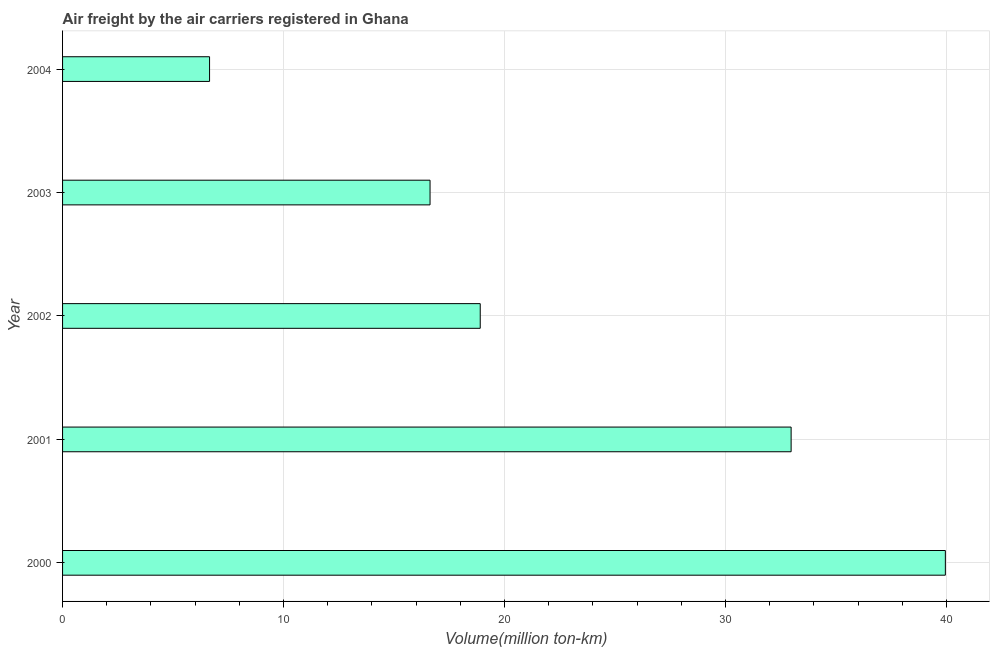Does the graph contain any zero values?
Offer a terse response. No. What is the title of the graph?
Your answer should be compact. Air freight by the air carriers registered in Ghana. What is the label or title of the X-axis?
Give a very brief answer. Volume(million ton-km). What is the air freight in 2002?
Offer a terse response. 18.9. Across all years, what is the maximum air freight?
Your answer should be very brief. 39.95. Across all years, what is the minimum air freight?
Your response must be concise. 6.65. In which year was the air freight maximum?
Your answer should be very brief. 2000. In which year was the air freight minimum?
Your answer should be compact. 2004. What is the sum of the air freight?
Your response must be concise. 115.1. What is the difference between the air freight in 2001 and 2003?
Your answer should be very brief. 16.34. What is the average air freight per year?
Provide a short and direct response. 23.02. What is the median air freight?
Your response must be concise. 18.9. What is the ratio of the air freight in 2000 to that in 2003?
Provide a short and direct response. 2.4. Is the air freight in 2000 less than that in 2001?
Ensure brevity in your answer.  No. What is the difference between the highest and the second highest air freight?
Provide a short and direct response. 6.98. Is the sum of the air freight in 2003 and 2004 greater than the maximum air freight across all years?
Give a very brief answer. No. What is the difference between the highest and the lowest air freight?
Provide a short and direct response. 33.3. In how many years, is the air freight greater than the average air freight taken over all years?
Ensure brevity in your answer.  2. Are all the bars in the graph horizontal?
Your response must be concise. Yes. How many years are there in the graph?
Offer a very short reply. 5. What is the Volume(million ton-km) of 2000?
Ensure brevity in your answer.  39.95. What is the Volume(million ton-km) in 2001?
Ensure brevity in your answer.  32.97. What is the Volume(million ton-km) in 2002?
Provide a short and direct response. 18.9. What is the Volume(million ton-km) in 2003?
Your response must be concise. 16.63. What is the Volume(million ton-km) in 2004?
Offer a very short reply. 6.65. What is the difference between the Volume(million ton-km) in 2000 and 2001?
Keep it short and to the point. 6.98. What is the difference between the Volume(million ton-km) in 2000 and 2002?
Your answer should be very brief. 21.05. What is the difference between the Volume(million ton-km) in 2000 and 2003?
Ensure brevity in your answer.  23.32. What is the difference between the Volume(million ton-km) in 2000 and 2004?
Offer a terse response. 33.3. What is the difference between the Volume(million ton-km) in 2001 and 2002?
Your answer should be compact. 14.07. What is the difference between the Volume(million ton-km) in 2001 and 2003?
Provide a succinct answer. 16.34. What is the difference between the Volume(million ton-km) in 2001 and 2004?
Offer a very short reply. 26.32. What is the difference between the Volume(million ton-km) in 2002 and 2003?
Offer a very short reply. 2.27. What is the difference between the Volume(million ton-km) in 2002 and 2004?
Keep it short and to the point. 12.25. What is the difference between the Volume(million ton-km) in 2003 and 2004?
Ensure brevity in your answer.  9.98. What is the ratio of the Volume(million ton-km) in 2000 to that in 2001?
Your answer should be very brief. 1.21. What is the ratio of the Volume(million ton-km) in 2000 to that in 2002?
Your answer should be very brief. 2.11. What is the ratio of the Volume(million ton-km) in 2000 to that in 2003?
Your answer should be very brief. 2.4. What is the ratio of the Volume(million ton-km) in 2000 to that in 2004?
Keep it short and to the point. 6.01. What is the ratio of the Volume(million ton-km) in 2001 to that in 2002?
Make the answer very short. 1.74. What is the ratio of the Volume(million ton-km) in 2001 to that in 2003?
Offer a very short reply. 1.98. What is the ratio of the Volume(million ton-km) in 2001 to that in 2004?
Your answer should be very brief. 4.96. What is the ratio of the Volume(million ton-km) in 2002 to that in 2003?
Keep it short and to the point. 1.14. What is the ratio of the Volume(million ton-km) in 2002 to that in 2004?
Make the answer very short. 2.84. 